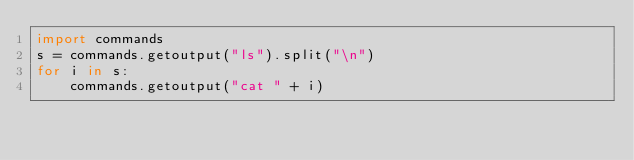Convert code to text. <code><loc_0><loc_0><loc_500><loc_500><_Python_>import commands
s = commands.getoutput("ls").split("\n")
for i in s:
    commands.getoutput("cat " + i)</code> 